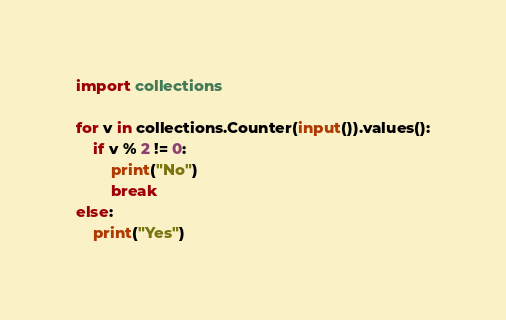Convert code to text. <code><loc_0><loc_0><loc_500><loc_500><_Python_>import collections

for v in collections.Counter(input()).values():
    if v % 2 != 0:
        print("No")
        break
else:
    print("Yes")</code> 